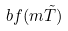Convert formula to latex. <formula><loc_0><loc_0><loc_500><loc_500>b f ( m \tilde { T } )</formula> 